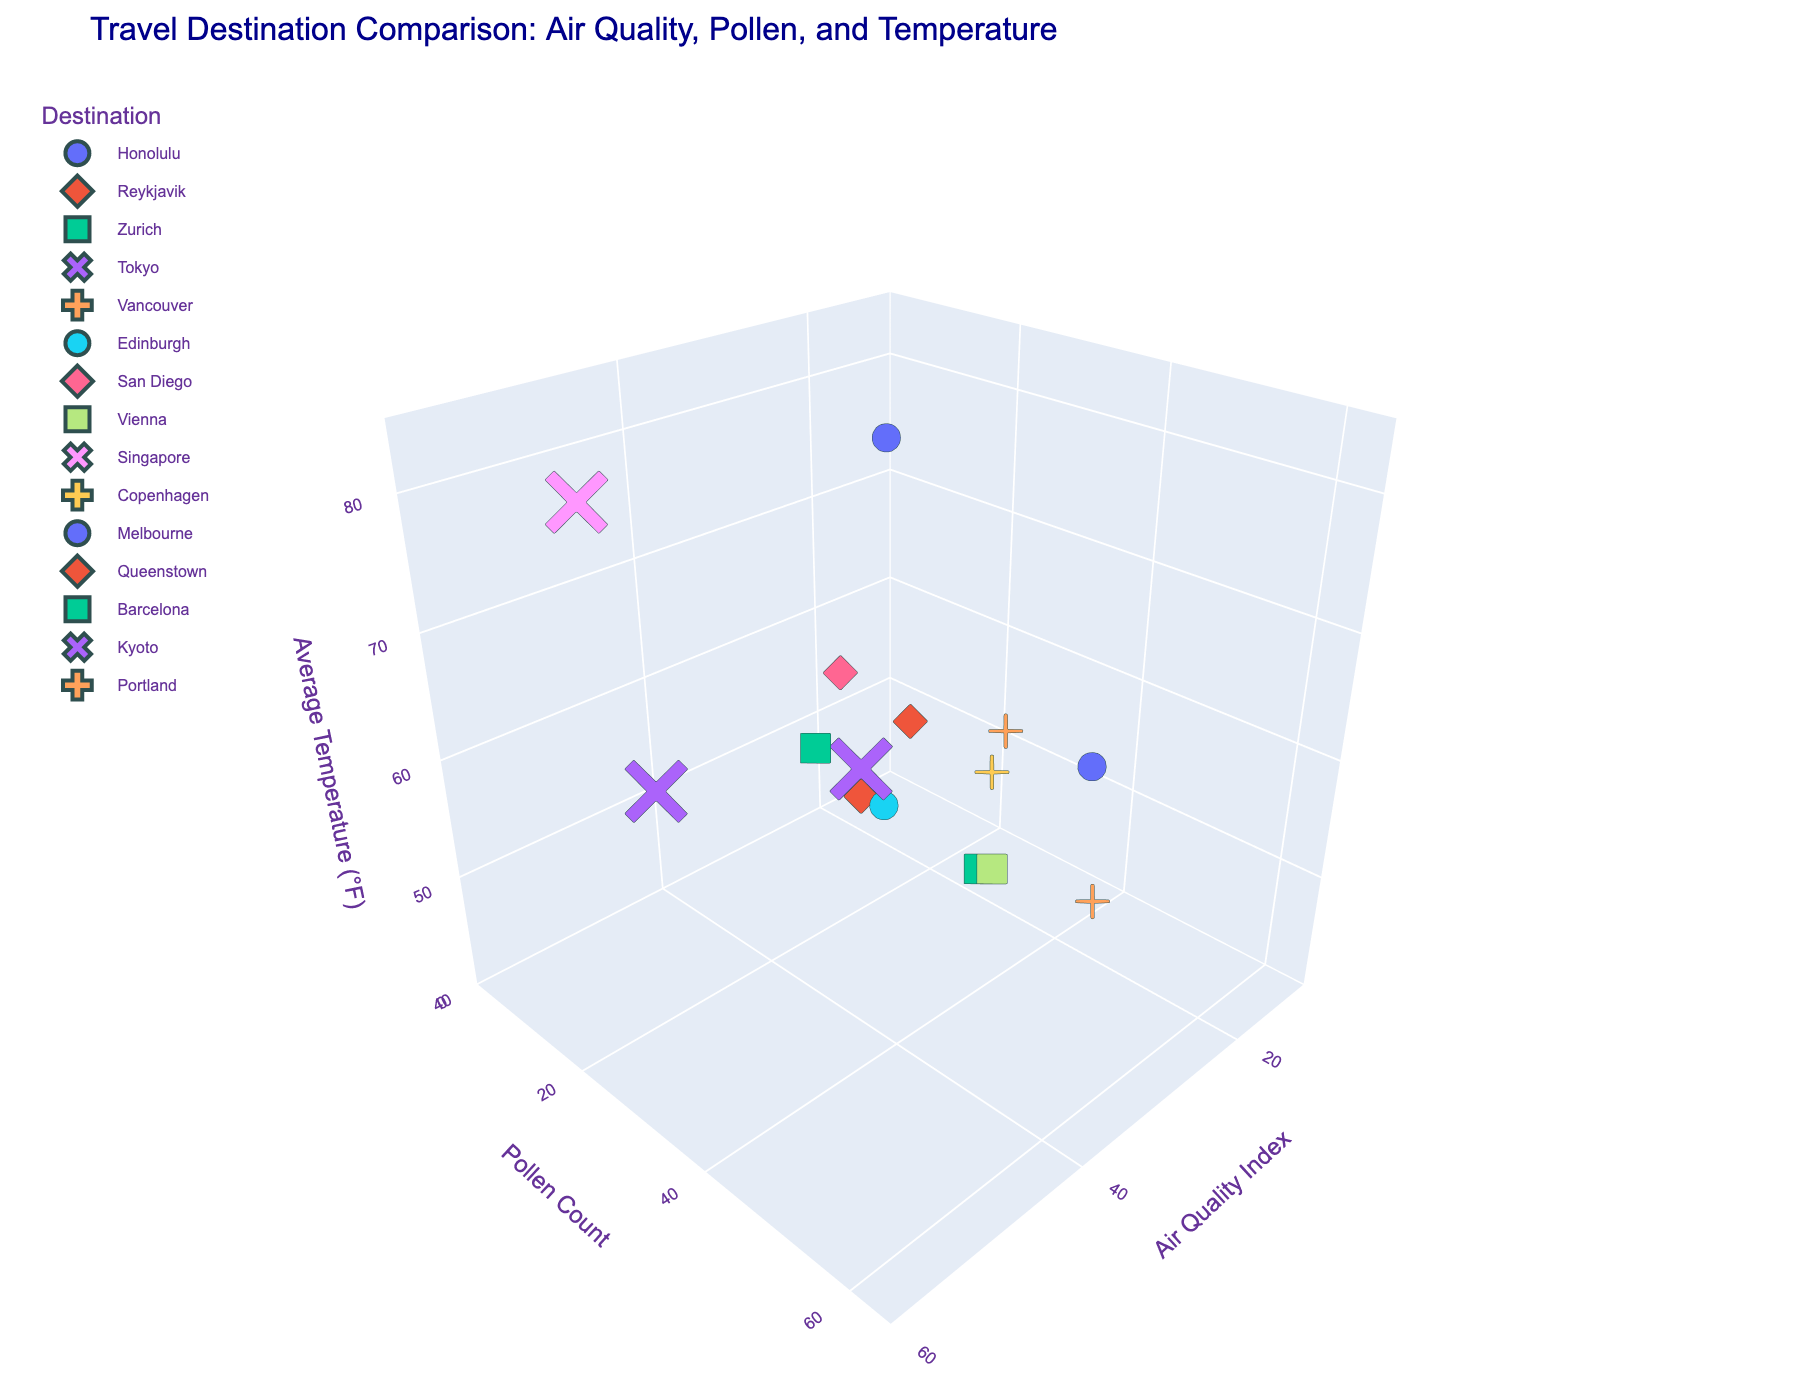Which destination has the highest Air Quality Index? Observe the 3D scatter plot and identify the destination with the highest value on the Air Quality Index axis.
Answer: Singapore What is the range of the Pollen Count axis? Look at the minimum and maximum tick values on the Pollen Count axis.
Answer: 0 to 65 Which destination has the lowest average temperature? Identify the data point with the lowest value on the Average Temperature axis and read off the corresponding destination label.
Answer: Reykjavik Which two destinations have the closest average temperatures? Compare the values on the Average Temperature axis and find the two closest values.
Answer: Vancouver and Kyoto What is the most common Air Quality Index value range in this dataset? Group the Air Quality Index values into ranges and identify the range with the most destinations.
Answer: 30-40 How does the Pollen Count of Barcelona compare to that of Zurich? Identify the Pollen Count values for both destinations and compare them.
Answer: Zurich has higher Pollen Count Which destination has the highest combination of Air Quality Index and Pollen Count? Calculate the sum of Air Quality Index and Pollen Count for each destination and identify the highest value.
Answer: Melbourne What is the ratio of Air Quality Index to Average Temperature for San Diego? Divide the Air Quality Index value by the Average Temperature value for San Diego.
Answer: 42/70 ≈ 0.6 Which destination has the highest average temperature among those with an Air Quality Index less than 30? Filter the destinations with Air Quality Index less than 30, then identify the one with the highest average temperature.
Answer: Vancouver How does the camera view angle impact the interpretation of relative distances between the data points? Consider the effect of viewing the 3D scatter plot from different angles on the perceived distances between the data points.
Answer: Changes in camera angle can distort or emphasize distances 